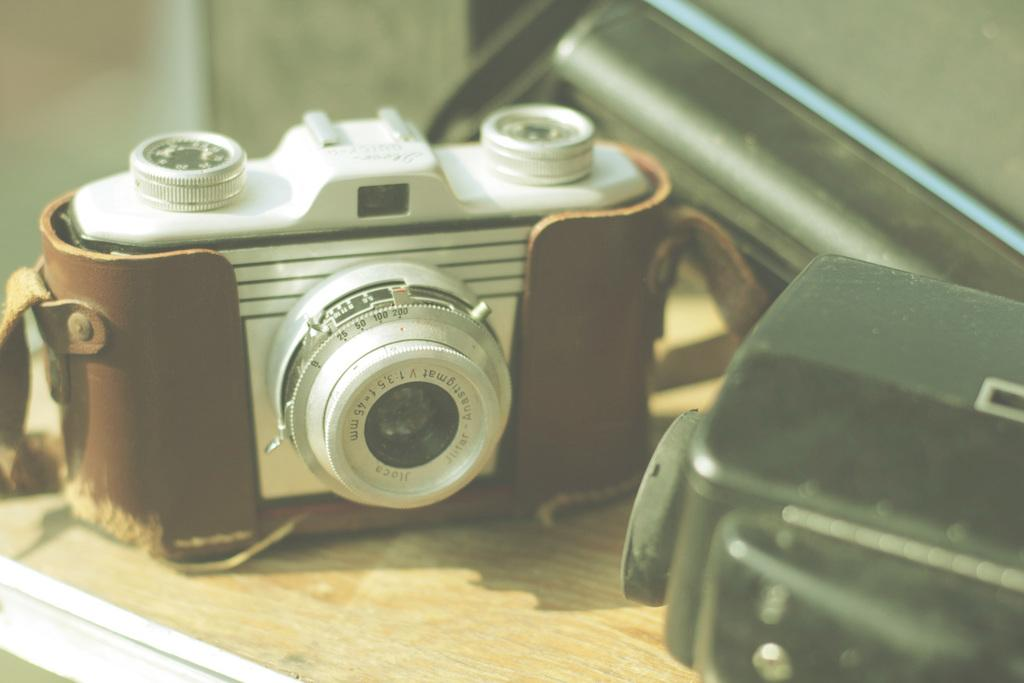What is the main object in the image? There is a camera in the image. What else can be seen in the image besides the camera? Other objects are present in the image. On what surface are the objects placed? The objects are placed on a wooden floor. What is visible in the background of the image? There is a wall in the background of the image. Can you see a goose nesting on the boat in the image? There is no boat or goose present in the image; it features a camera and other objects on a wooden floor with a wall in the background. 